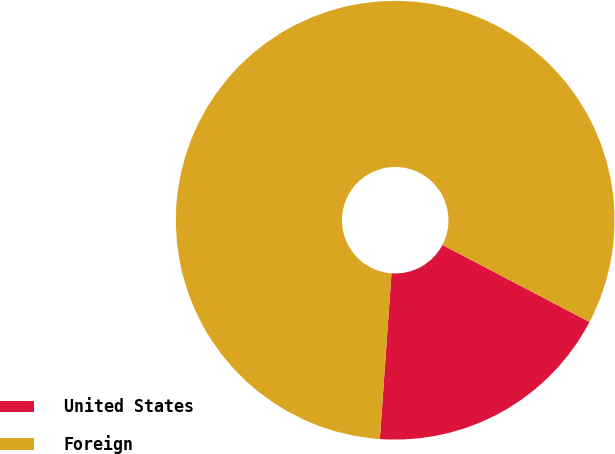Convert chart to OTSL. <chart><loc_0><loc_0><loc_500><loc_500><pie_chart><fcel>United States<fcel>Foreign<nl><fcel>18.44%<fcel>81.56%<nl></chart> 